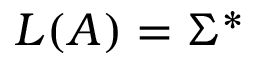<formula> <loc_0><loc_0><loc_500><loc_500>L ( A ) = \Sigma ^ { * }</formula> 